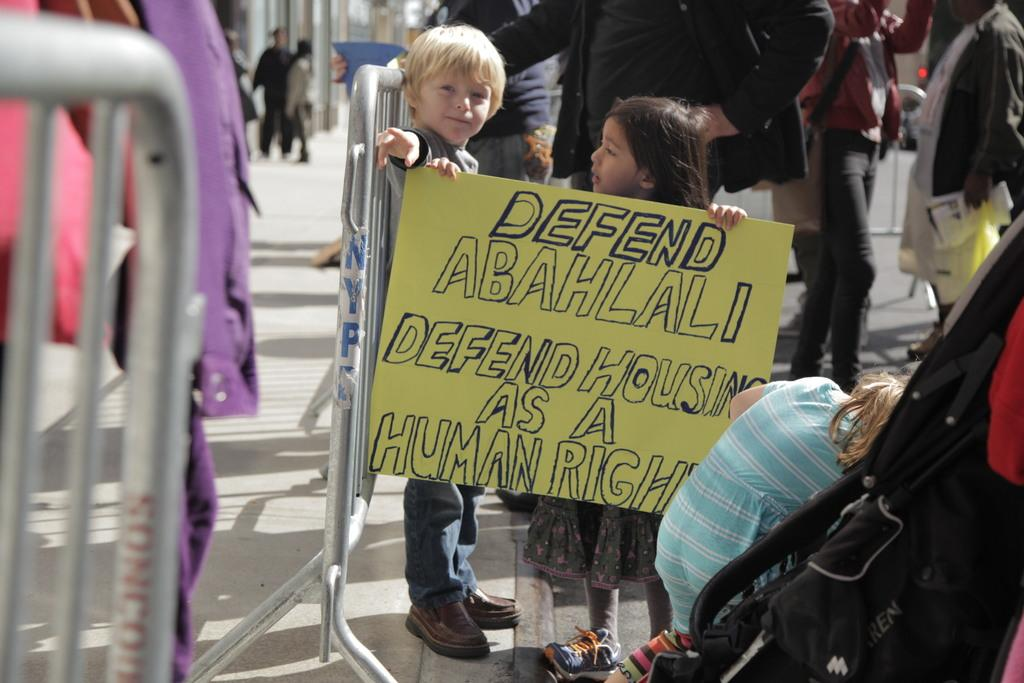What is happening on the right side of the image? There are many people standing on the right side of the image. Can you describe the activity of some people in the image? Some people are walking behind a fence. What are the kids doing in the front of the image? Kids are holding a banner in the front of the image. What color are the toes of the person walking behind the fence? There is no mention of toes or their color in the image, as it focuses on people standing, walking, and holding a banner. 